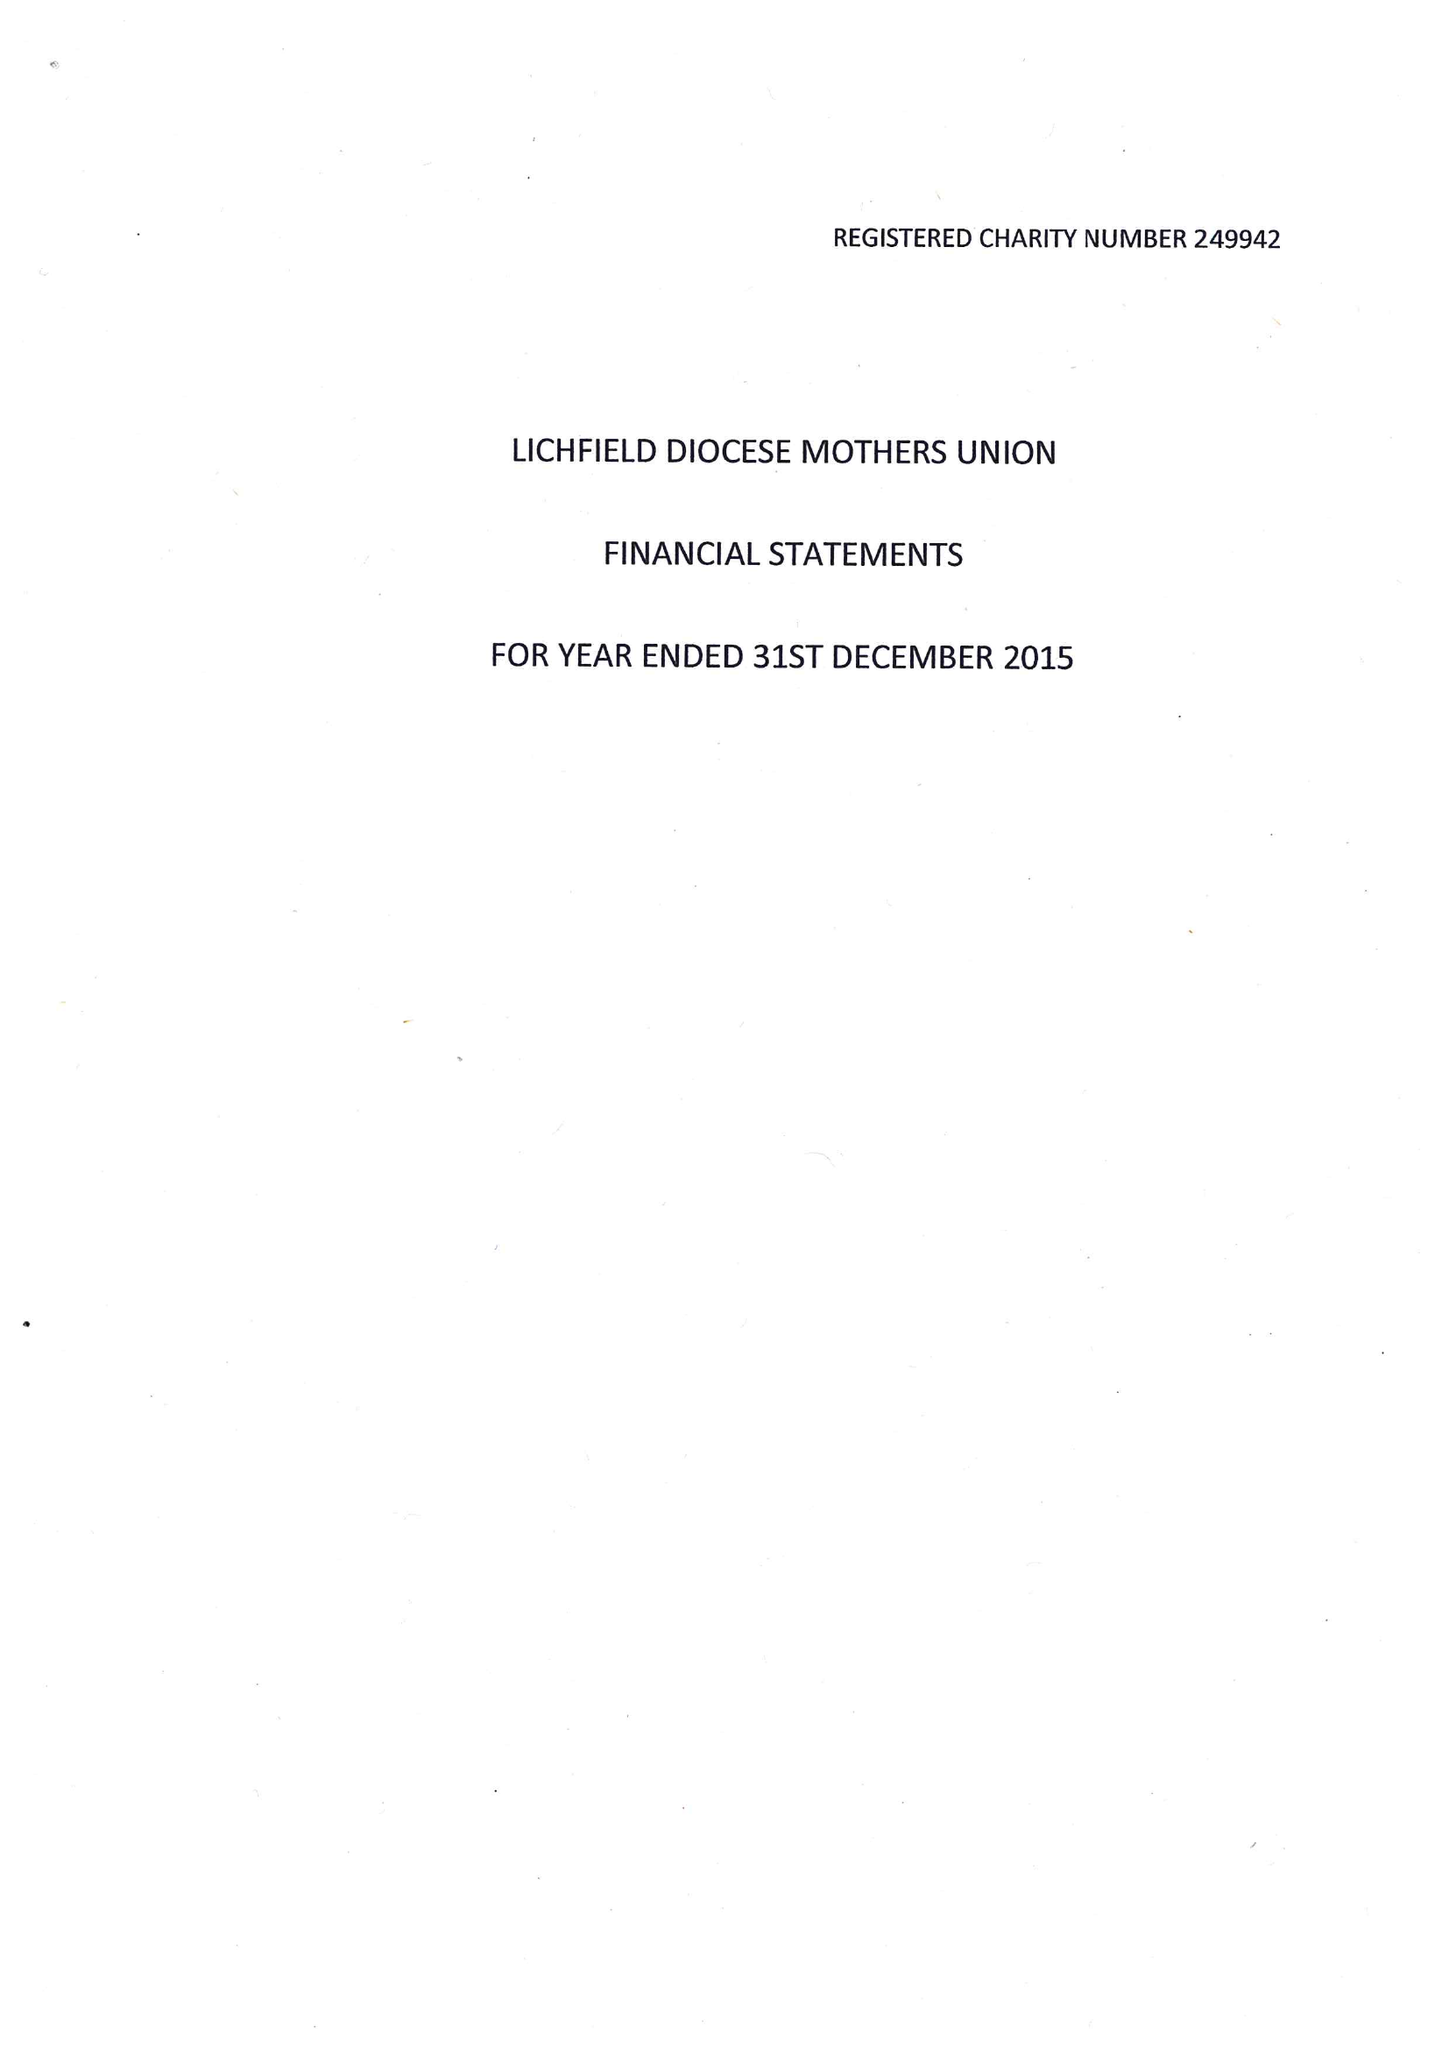What is the value for the charity_name?
Answer the question using a single word or phrase. The Mothers' Union Diocese Of Lichfield 